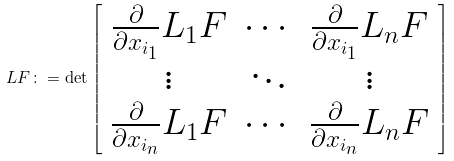Convert formula to latex. <formula><loc_0><loc_0><loc_500><loc_500>L F \colon = \det \left [ \begin{array} { c c c } \frac { \partial } { \partial x _ { i _ { 1 } } } L _ { 1 } F & \cdots & \frac { \partial } { \partial x _ { i _ { 1 } } } L _ { n } F \\ \vdots & \ddots & \vdots \\ \frac { \partial } { \partial x _ { i _ { n } } } L _ { 1 } F & \cdots & \frac { \partial } { \partial x _ { i _ { n } } } L _ { n } F \end{array} \right ]</formula> 